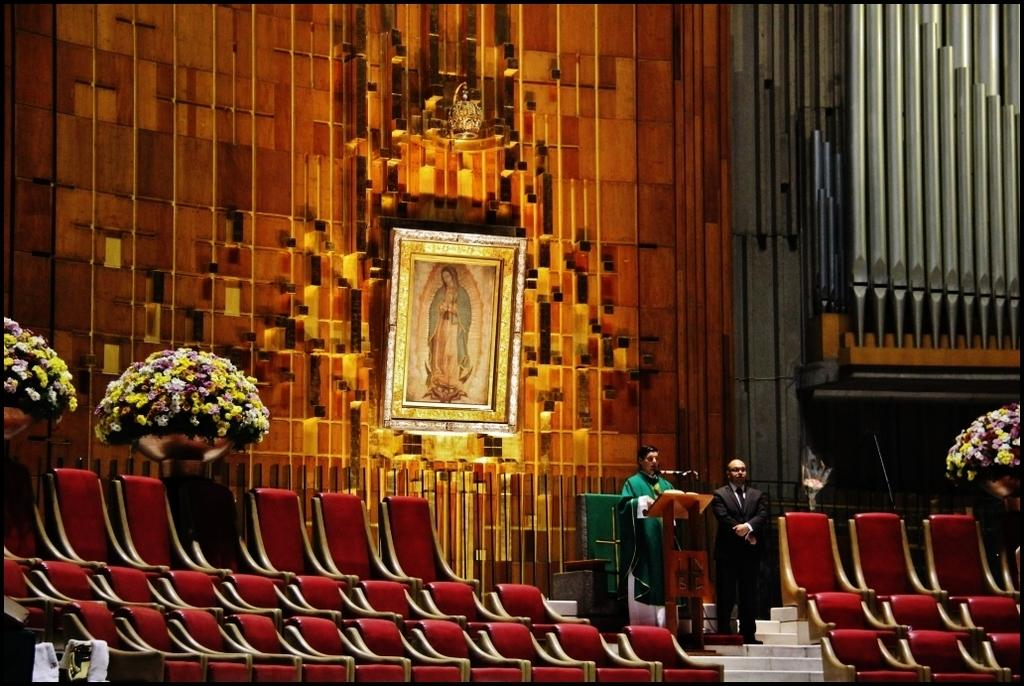How many men are in the image? There are two men in the image. What is one of the men doing in the image? One man is standing at a podium. What is the man at the podium using to amplify his voice? The man at the podium is talking on a microphone. What type of furniture is present in the image? There are chairs in the image. What type of decorative items can be seen in the image? There are flower pots in the image. What can be seen in the background of the image? There is a wall and a frame in the background of the image. What type of fog can be seen in the image? There is no fog present in the image. How many degrees can be seen in the image? There are no degrees visible in the image. 